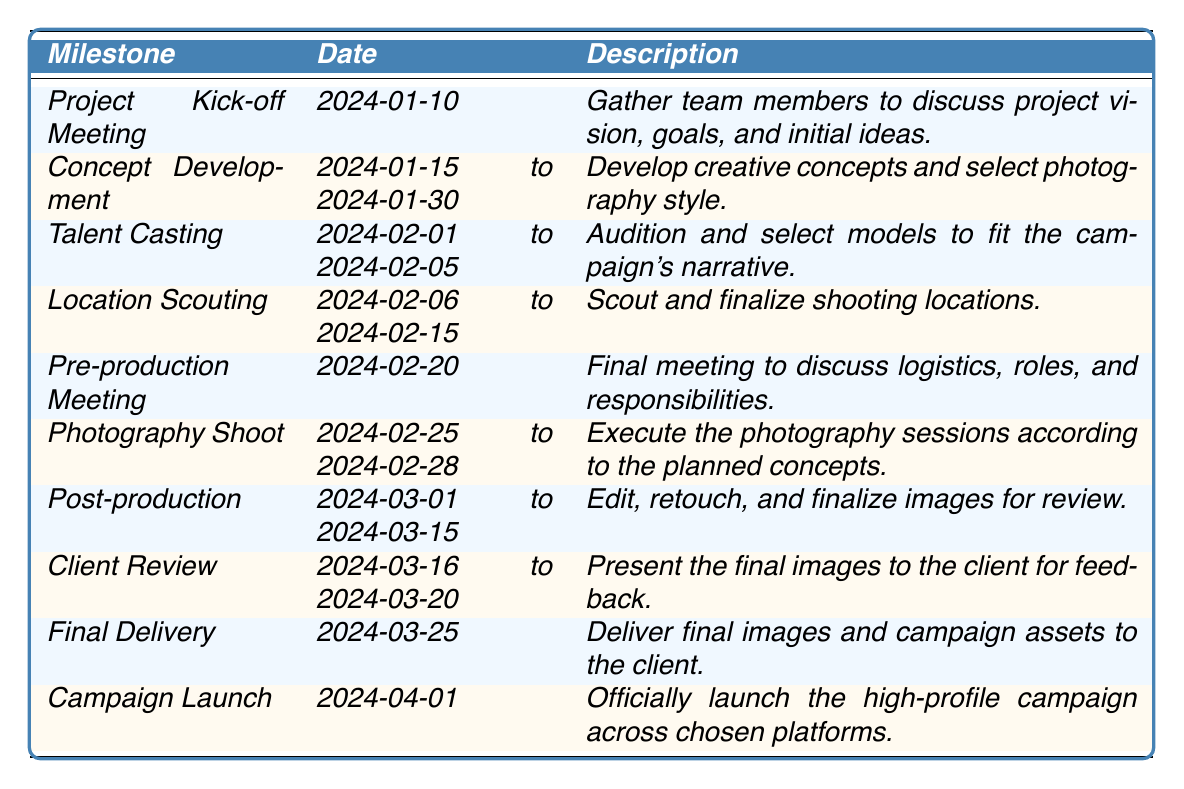What is the date of the Project Kick-off Meeting? The table lists the milestone "Project Kick-off Meeting," which shows the date is "2024-01-10."
Answer: 2024-01-10 How long does the Concept Development phase last? The table indicates that the milestone "Concept Development" spans from "2024-01-15 to 2024-01-30," which is a total of 15 days.
Answer: 15 days What is the last milestone before the Campaign Launch? By examining the table, the last milestone before "Campaign Launch" is "Final Delivery," which takes place on "2024-03-25."
Answer: Final Delivery Is there a milestone for location scouting? The table has a milestone called "Location Scouting," confirming its existence within the project timeline.
Answer: Yes How many days are there between the end of the Photography Shoot and the start of Post-production? The Photography Shoot ends on "2024-02-28," and Post-production starts on "2024-03-01." This indicates there is one day in between.
Answer: 1 day What is the duration of the Post-production phase? The table shows that Post-production occurs from "2024-03-01 to 2024-03-15," which totals 15 days.
Answer: 15 days Which milestone comes directly after the Talent Casting? According to the table, the milestone that follows "Talent Casting," which occurs from "2024-02-01 to 2024-02-05," is "Location Scouting."
Answer: Location Scouting How many total days are allocated for the entire Photography Shoot? The Photography Shoot is scheduled from "2024-02-25 to 2024-02-28," which is 4 days in total.
Answer: 4 days What are the main tasks associated with the Client Review milestone? The table mentions that during the "Client Review" milestone, the task is to "Present the final images to the client for feedback."
Answer: Presenting final images for feedback If the Concept Development overlaps with Talent Casting, during what period do they both occur? Concept Development lasts until "2024-01-30," and Talent Casting starts on "2024-02-01." Therefore, they do not overlap.
Answer: No overlap 